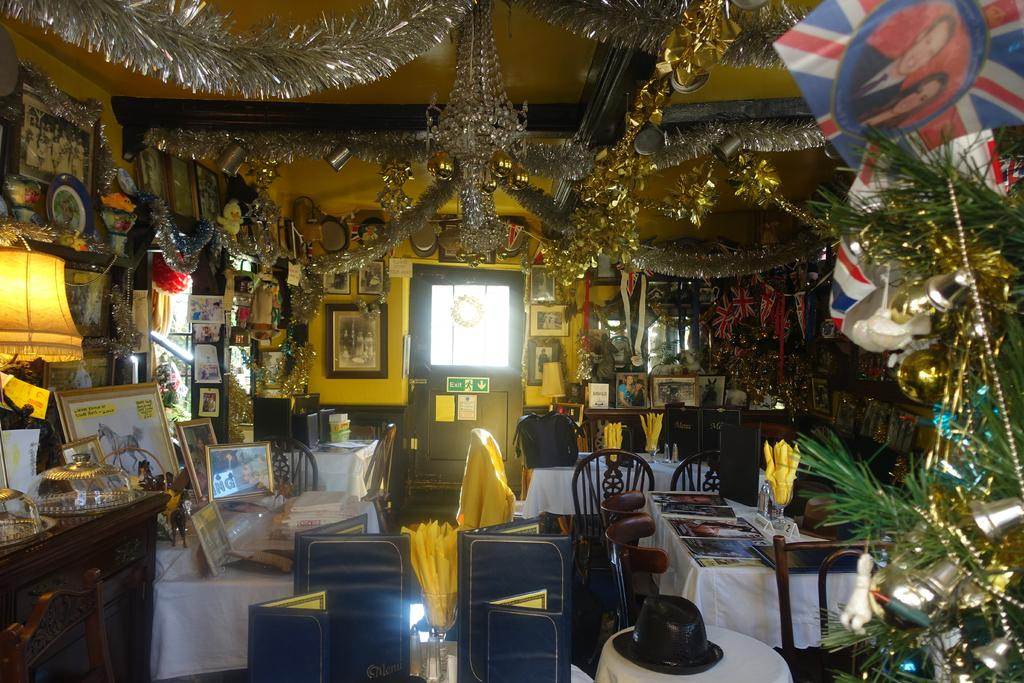What type of space is depicted in the image? The image contains a room. What furniture is present in the room? There are chairs and tables in the room. How is the room decorated? The room is decorated with decorative items. What can be seen attached to the wall in the room? There are photographs attached to the wall in the room. What type of eggnog is being served in the room? There is no eggnog present in the image; it only shows a room with chairs, tables, decorative items, and photographs on the wall. 